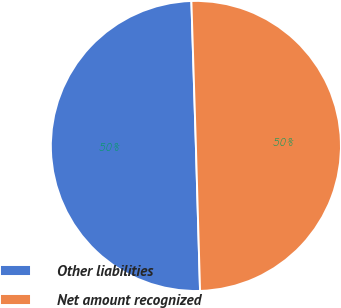Convert chart. <chart><loc_0><loc_0><loc_500><loc_500><pie_chart><fcel>Other liabilities<fcel>Net amount recognized<nl><fcel>49.96%<fcel>50.04%<nl></chart> 